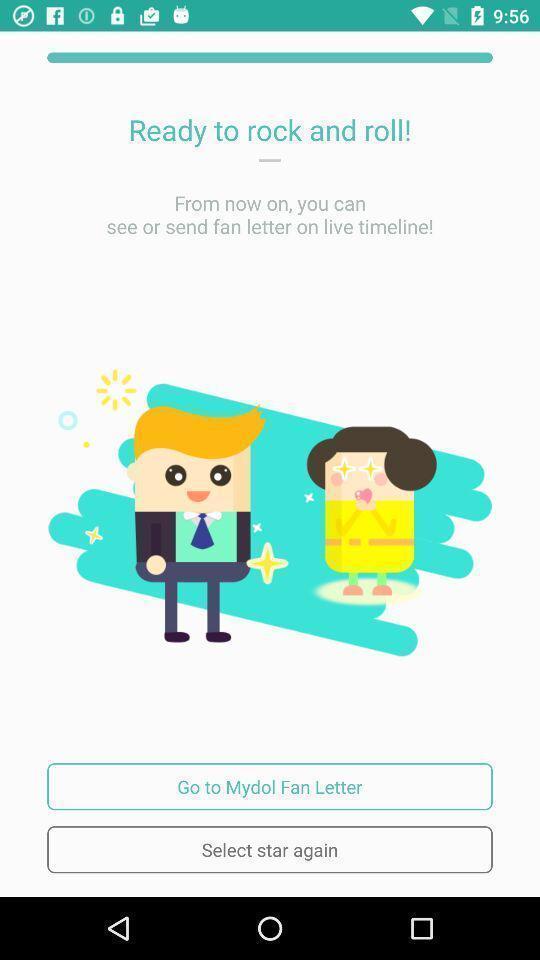Give me a narrative description of this picture. Starting page. 